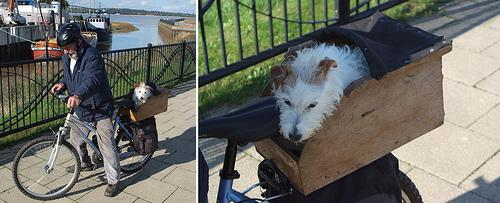Identify the primary and secondary subjects in the image and describe their activities. A man is riding a bike with a wooden carrier, while a small brown and white dog with brown ears sits inside the box. Use a creative language style to express the main subject and their actions. A man embarks on a scenic adventure with his small, white and brown canine companion, who looks back to safety tucked in a wooden carrier. Write a brief and casual description of the main action in the image. A man on a bike is taking his dog, who's chilling in a basket, for a ride by the water. Explain what the dog looks like and where it is situated in the image. The small white and brown dog with brown ears and a lot of hair looks scared while it sits in a wooden box on the back of a bike. Describe the image by focusing on the various objects in the scene. Black iron fences, stone-tiled sidewalk, wooden box with dog inside, black bike seat, silver bicycle ridden by a man taking his dog for a ride. Explain the contents of the image from the point of view of a bystander. As I saw a man riding a bike, I noticed his little, frightened dog sitting in a wooden box behind him, while boats floated nearby. Express the scene in the image with an emphasis on the man and his bicycle. A middle-aged man wearing a helmet is riding a silver and black bike, taking his dog for a ride, in a wooden carrying basket. Discuss the scene in the image by emphasizing the location and background objects. The image captures a man riding a bike along a concrete tile paved walkway, with black iron fences, and a river with boats in the background. Mention what the man in the image is doing, including his clothing and safety gear. The man is riding a bike wearing a navy colored jacket, khaki pants, brown shoes, and a black helmet. Describe the waterfront area, focusing on the boats and natural features. The image features a river with boats, including a red boat docked in an inlet, pretty blue water, and shore line at a distance. 